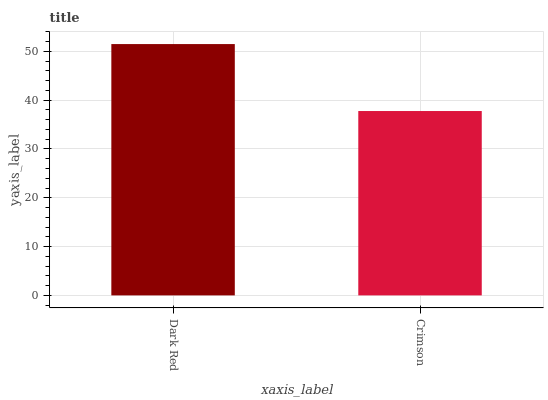Is Crimson the minimum?
Answer yes or no. Yes. Is Dark Red the maximum?
Answer yes or no. Yes. Is Crimson the maximum?
Answer yes or no. No. Is Dark Red greater than Crimson?
Answer yes or no. Yes. Is Crimson less than Dark Red?
Answer yes or no. Yes. Is Crimson greater than Dark Red?
Answer yes or no. No. Is Dark Red less than Crimson?
Answer yes or no. No. Is Dark Red the high median?
Answer yes or no. Yes. Is Crimson the low median?
Answer yes or no. Yes. Is Crimson the high median?
Answer yes or no. No. Is Dark Red the low median?
Answer yes or no. No. 